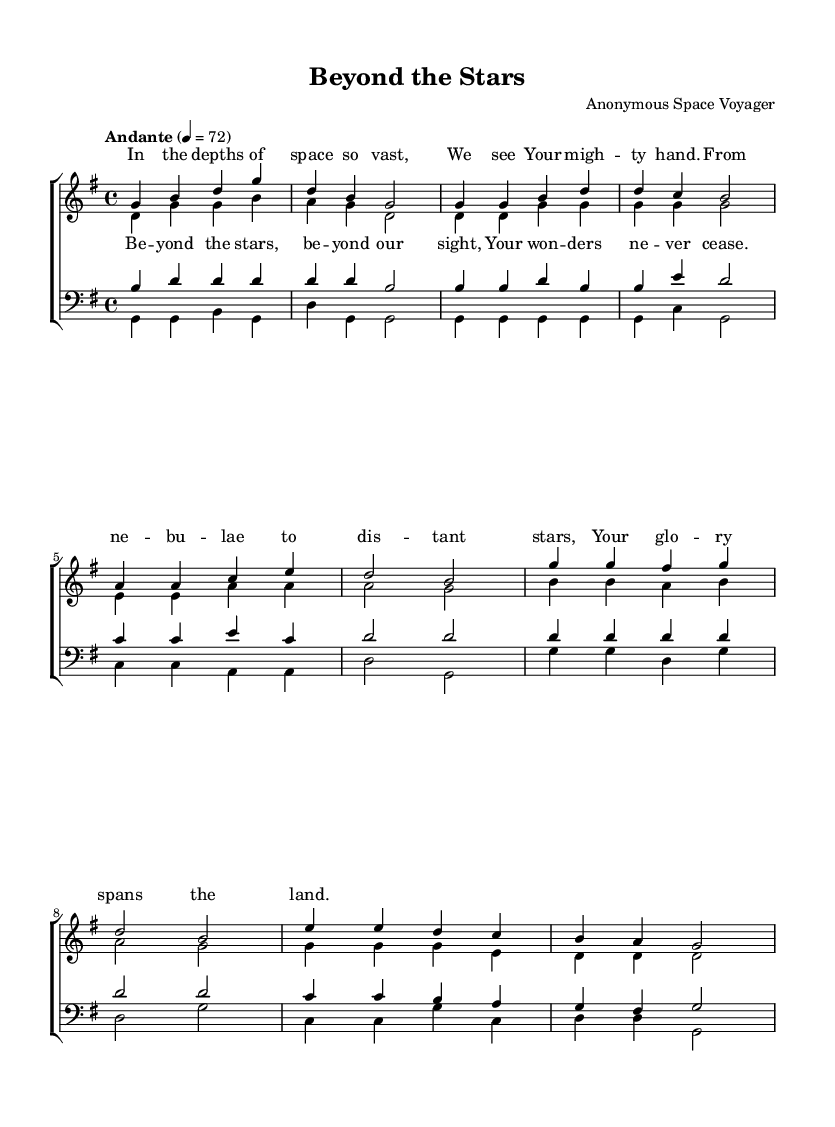What is the key signature of this music? The key signature is indicated at the beginning of the staff. In this case, there is one sharp (F#) in the key, indicating that it is G major.
Answer: G major What is the time signature of this music? The time signature is found at the beginning of the piece, showing the number of beats in a measure and what note value gets the beat. Here, it indicates 4 beats per measure with a quarter note receiving one beat, which represents a standard 4/4 time.
Answer: 4/4 What is the tempo marking and its value? The tempo marking suggests how fast the piece should be played. The marking "Andante" indicates a moderate walking pace, and the specific speed is set to 72 beats per minute.
Answer: Andante, 72 How many voices are utilized in this hymn? To determine the number of voices, we can count the distinct vocal parts listed in the piece. There are two parts for women's voices (soprano and alto) and two for men's voices (tenor and bass), resulting in a total of four voices.
Answer: Four What is the primary theme expressed in the lyrics? The lyrics speak of awe and reverence towards God's creation, mentioning the vastness of space and the glory of the divine. This reflects the central theme often found in hymns that celebrate celestial beauty and spirituality.
Answer: God's creation In which section do the sopranos sing the chorus? The chorus follows the verse, and in this score, it is indicated right after the lyrical lines for the sopranos. This can be visually identified in the layout under the soprano part, confirming that they sing this section distinctively.
Answer: After the verse What emotions are conveyed through the musical phrasing in the piece? The phrasing in this hymn, with its rising melodic lines and harmonic structures, conveys a sense of grandeur and reverence, providing an uplifting and spiritual experience for the singers and listeners alike.
Answer: Grandeur and reverence 